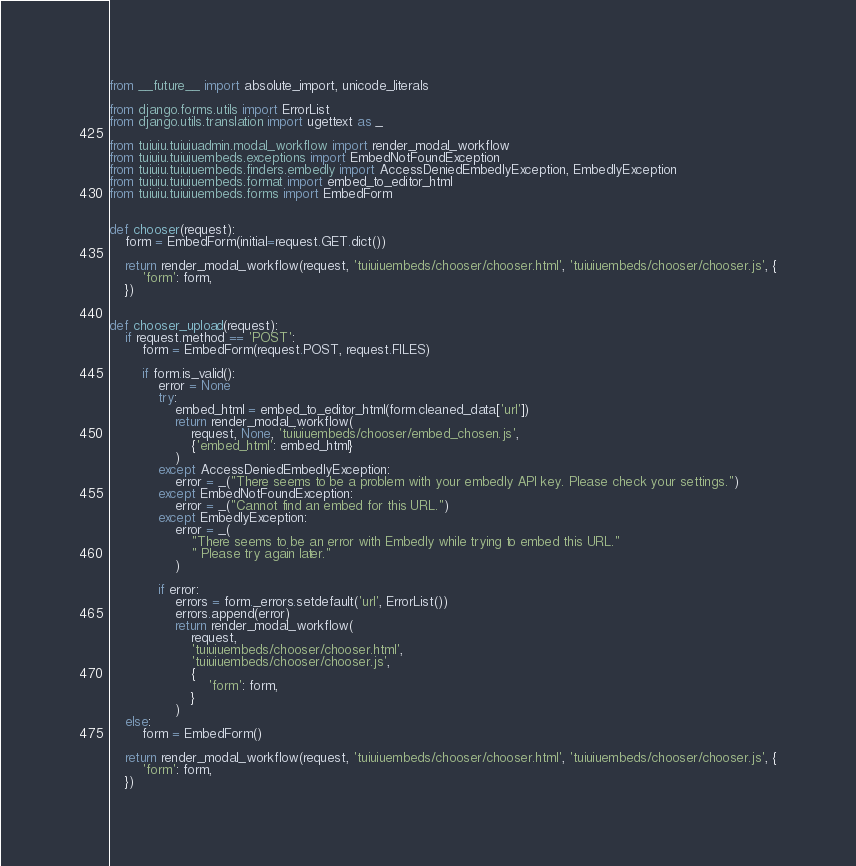<code> <loc_0><loc_0><loc_500><loc_500><_Python_>from __future__ import absolute_import, unicode_literals

from django.forms.utils import ErrorList
from django.utils.translation import ugettext as _

from tuiuiu.tuiuiuadmin.modal_workflow import render_modal_workflow
from tuiuiu.tuiuiuembeds.exceptions import EmbedNotFoundException
from tuiuiu.tuiuiuembeds.finders.embedly import AccessDeniedEmbedlyException, EmbedlyException
from tuiuiu.tuiuiuembeds.format import embed_to_editor_html
from tuiuiu.tuiuiuembeds.forms import EmbedForm


def chooser(request):
    form = EmbedForm(initial=request.GET.dict())

    return render_modal_workflow(request, 'tuiuiuembeds/chooser/chooser.html', 'tuiuiuembeds/chooser/chooser.js', {
        'form': form,
    })


def chooser_upload(request):
    if request.method == 'POST':
        form = EmbedForm(request.POST, request.FILES)

        if form.is_valid():
            error = None
            try:
                embed_html = embed_to_editor_html(form.cleaned_data['url'])
                return render_modal_workflow(
                    request, None, 'tuiuiuembeds/chooser/embed_chosen.js',
                    {'embed_html': embed_html}
                )
            except AccessDeniedEmbedlyException:
                error = _("There seems to be a problem with your embedly API key. Please check your settings.")
            except EmbedNotFoundException:
                error = _("Cannot find an embed for this URL.")
            except EmbedlyException:
                error = _(
                    "There seems to be an error with Embedly while trying to embed this URL."
                    " Please try again later."
                )

            if error:
                errors = form._errors.setdefault('url', ErrorList())
                errors.append(error)
                return render_modal_workflow(
                    request,
                    'tuiuiuembeds/chooser/chooser.html',
                    'tuiuiuembeds/chooser/chooser.js',
                    {
                        'form': form,
                    }
                )
    else:
        form = EmbedForm()

    return render_modal_workflow(request, 'tuiuiuembeds/chooser/chooser.html', 'tuiuiuembeds/chooser/chooser.js', {
        'form': form,
    })
</code> 